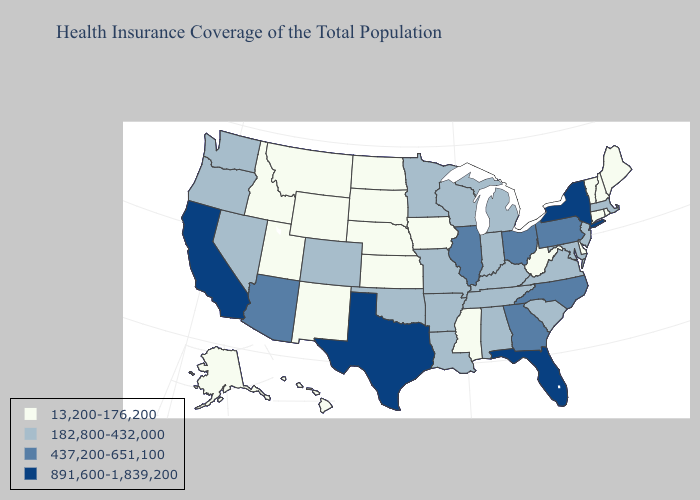Which states have the highest value in the USA?
Be succinct. California, Florida, New York, Texas. Does the map have missing data?
Keep it brief. No. Name the states that have a value in the range 437,200-651,100?
Keep it brief. Arizona, Georgia, Illinois, North Carolina, Ohio, Pennsylvania. What is the value of Florida?
Short answer required. 891,600-1,839,200. What is the lowest value in the USA?
Concise answer only. 13,200-176,200. Does North Dakota have a lower value than New Jersey?
Short answer required. Yes. What is the value of New Jersey?
Be succinct. 182,800-432,000. What is the lowest value in states that border Montana?
Quick response, please. 13,200-176,200. Does the first symbol in the legend represent the smallest category?
Short answer required. Yes. What is the value of South Dakota?
Be succinct. 13,200-176,200. What is the highest value in the Northeast ?
Answer briefly. 891,600-1,839,200. What is the highest value in states that border Maryland?
Short answer required. 437,200-651,100. Name the states that have a value in the range 891,600-1,839,200?
Write a very short answer. California, Florida, New York, Texas. What is the highest value in the West ?
Write a very short answer. 891,600-1,839,200. Name the states that have a value in the range 437,200-651,100?
Answer briefly. Arizona, Georgia, Illinois, North Carolina, Ohio, Pennsylvania. 